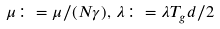<formula> <loc_0><loc_0><loc_500><loc_500>\mu \colon = \mu / ( N \gamma ) , \, \lambda \colon = \lambda T _ { g } d / 2</formula> 